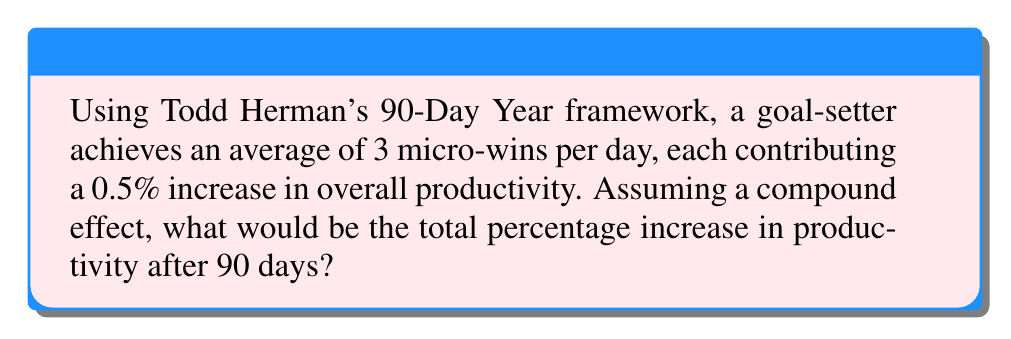Can you solve this math problem? Let's approach this step-by-step using the compound interest formula:

1) In Herman's framework, we're looking at daily compounding over 90 days.

2) Each day, there are 3 micro-wins, each contributing 0.5%. So the daily increase is:
   $3 \times 0.5\% = 1.5\%$ or 0.015 in decimal form.

3) The compound interest formula is:
   $A = P(1 + r)^n$
   Where:
   $A$ = Final amount
   $P$ = Principal (initial amount, in this case 1 or 100%)
   $r$ = Daily rate (0.015)
   $n$ = Number of days (90)

4) Plugging in our values:
   $A = 1(1 + 0.015)^{90}$

5) Calculate:
   $A = 1(1.015)^{90} \approx 3.7754$

6) This means the final productivity is about 377.54% of the initial productivity.

7) To find the percentage increase, we subtract the initial 100%:
   $377.54\% - 100\% = 277.54\%$

Thus, the total percentage increase in productivity after 90 days is approximately 277.54%.
Answer: 277.54% 